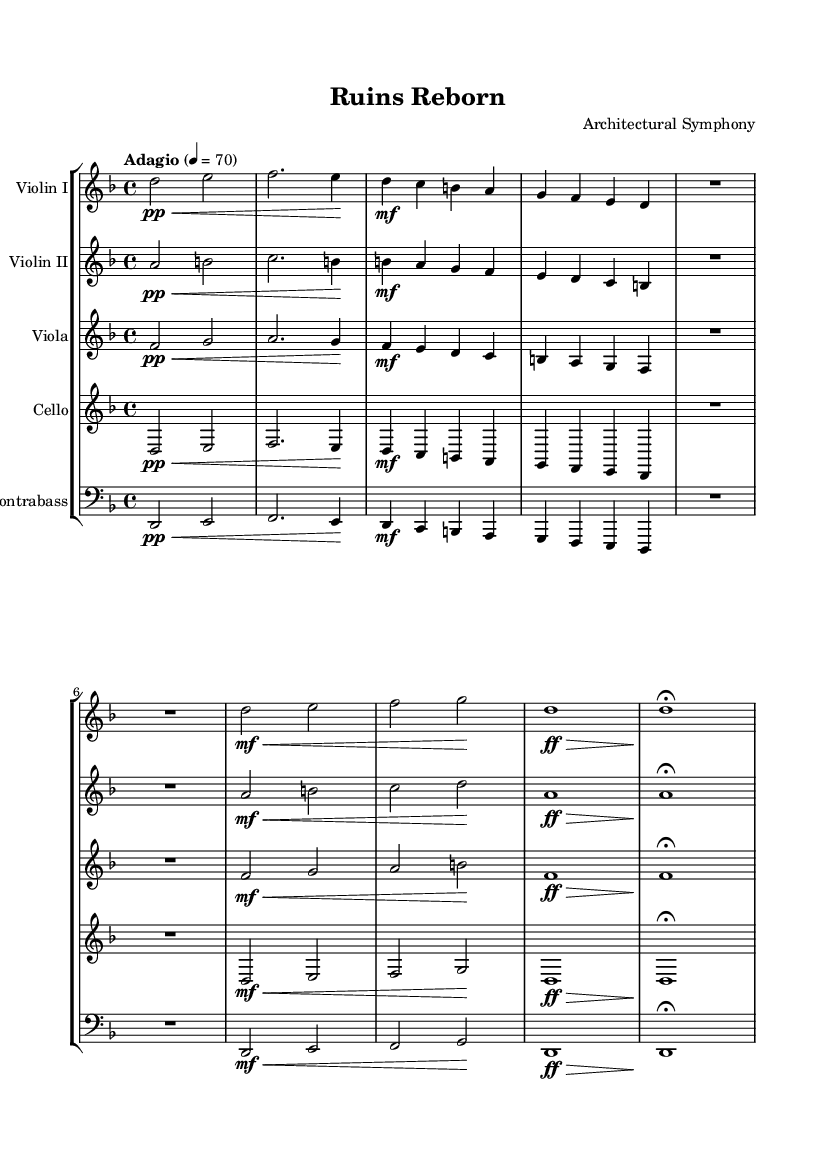What is the key signature of this music? The key signature is D minor, which has one flat (B flat).
Answer: D minor What is the time signature of this piece? The time signature indicated in the music is 4/4.
Answer: 4/4 What is the tempo marking for the symphony? The tempo marking is "Adagio," indicating a slow pace.
Answer: Adagio What instrument plays the highest part in this work? Violin I typically plays the highest notes within the orchestral texture.
Answer: Violin I How many themes are present in this symphony? The symphony has three distinct themes: Collapse, Desolation, and Rebirth.
Answer: Three What is the dynamic marking at the start of the piece? The dynamic marking at the beginning is p for pianissimo, indicating a very soft volume.
Answer: pianissimo What signifies the end of the piece in the coda? The coda concludes with a fermata over the final note, allowing it to be held longer.
Answer: fermata 